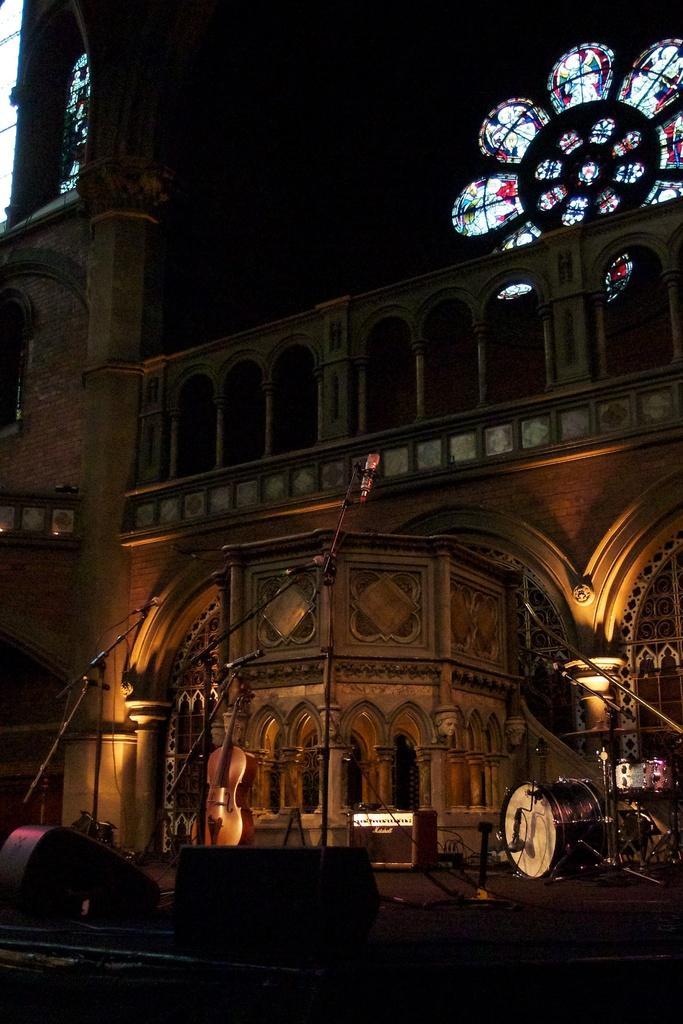Please provide a concise description of this image. This is an image clicked in the dark. At the bottom there are few objects in the dark. On the right side there is a drum set. Here I can see a building. In the top right-hand corner there is a stained glass. 